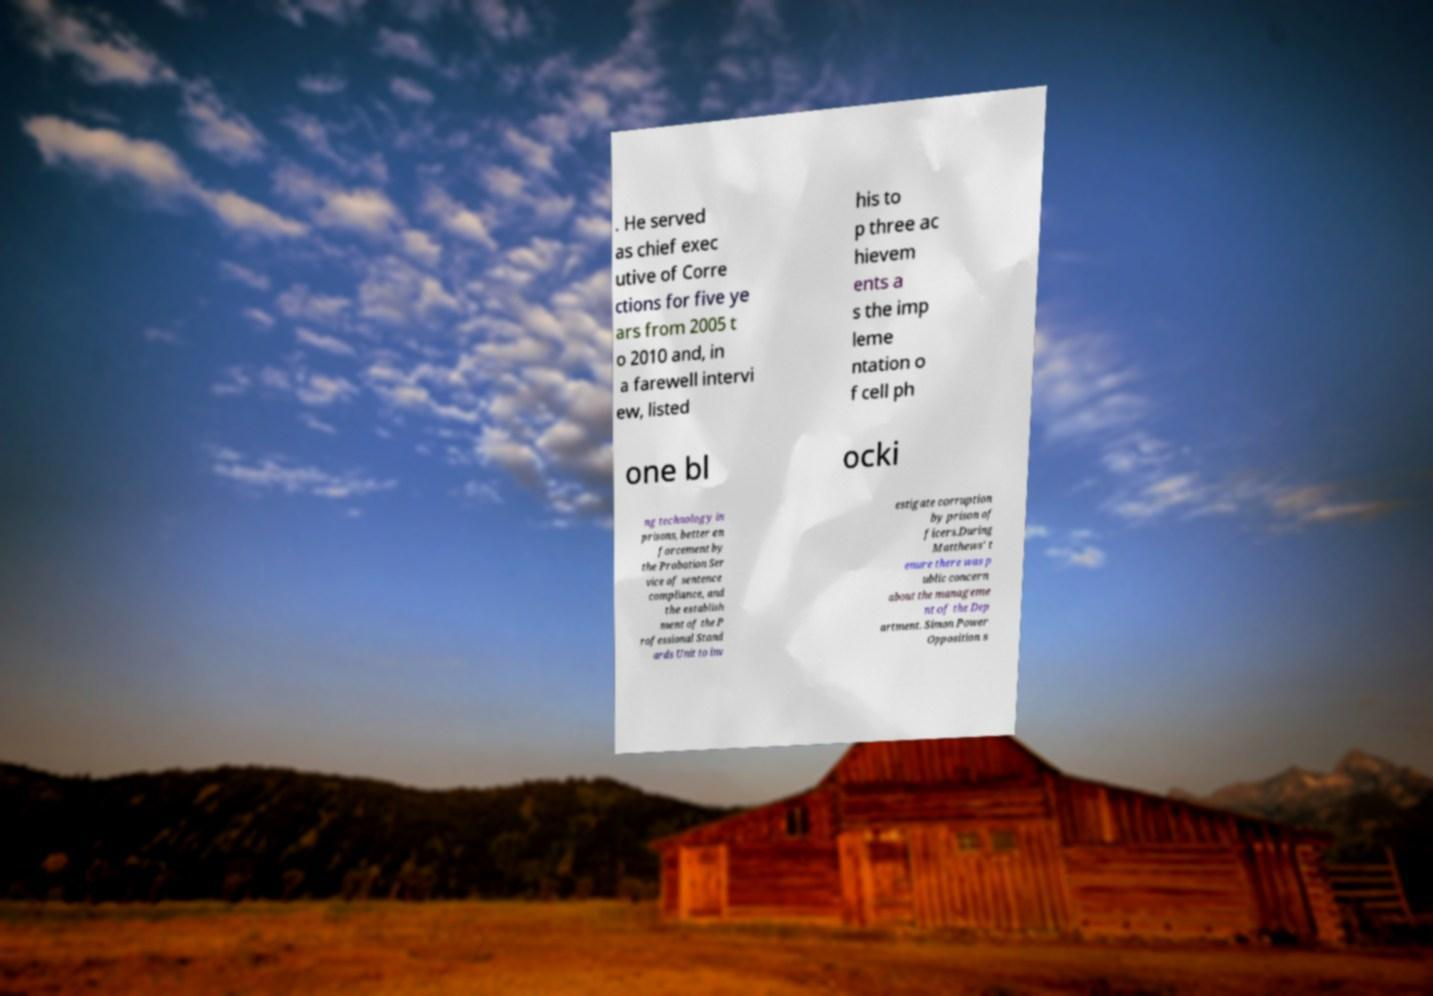What messages or text are displayed in this image? I need them in a readable, typed format. . He served as chief exec utive of Corre ctions for five ye ars from 2005 t o 2010 and, in a farewell intervi ew, listed his to p three ac hievem ents a s the imp leme ntation o f cell ph one bl ocki ng technology in prisons, better en forcement by the Probation Ser vice of sentence compliance, and the establish ment of the P rofessional Stand ards Unit to inv estigate corruption by prison of ficers.During Matthews' t enure there was p ublic concern about the manageme nt of the Dep artment. Simon Power Opposition s 